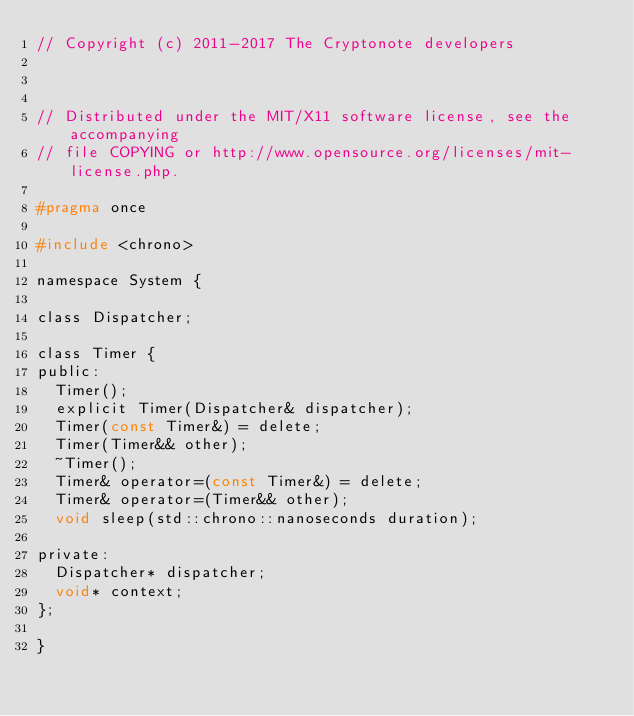<code> <loc_0><loc_0><loc_500><loc_500><_C_>// Copyright (c) 2011-2017 The Cryptonote developers
 
 
 
// Distributed under the MIT/X11 software license, see the accompanying
// file COPYING or http://www.opensource.org/licenses/mit-license.php.

#pragma once

#include <chrono>

namespace System {

class Dispatcher;

class Timer {
public:
  Timer();
  explicit Timer(Dispatcher& dispatcher);
  Timer(const Timer&) = delete;
  Timer(Timer&& other);
  ~Timer();
  Timer& operator=(const Timer&) = delete;
  Timer& operator=(Timer&& other);
  void sleep(std::chrono::nanoseconds duration);

private:
  Dispatcher* dispatcher;
  void* context;
};

}
</code> 